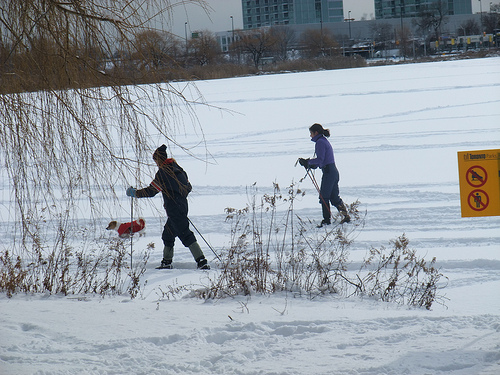How many kids? In the image, there appear to be two individuals who are likely children, enjoying their time in a snowy landscape, engaged in what seems to be playful activities. 